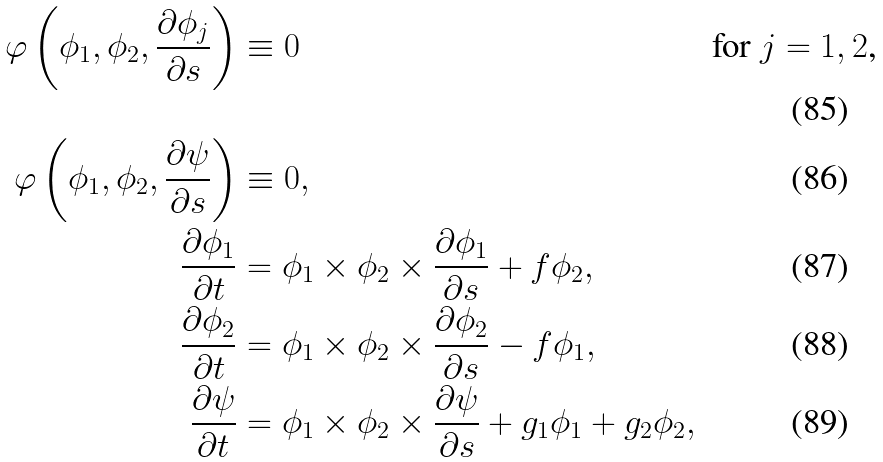Convert formula to latex. <formula><loc_0><loc_0><loc_500><loc_500>\varphi \left ( \phi _ { 1 } , \phi _ { 2 } , \frac { \partial \phi _ { j } } { \partial s } \right ) & \equiv 0 & & \text {for $j=1,2$,} \\ \varphi \left ( \phi _ { 1 } , \phi _ { 2 } , \frac { \partial \psi } { \partial s } \right ) & \equiv 0 , & & \\ \frac { \partial \phi _ { 1 } } { \partial t } & = \phi _ { 1 } \times \phi _ { 2 } \times \frac { \partial \phi _ { 1 } } { \partial s } + f \phi _ { 2 } , & & \\ \frac { \partial \phi _ { 2 } } { \partial t } & = \phi _ { 1 } \times \phi _ { 2 } \times \frac { \partial \phi _ { 2 } } { \partial s } - f \phi _ { 1 } , & & \\ \frac { \partial \psi } { \partial t } & = \phi _ { 1 } \times \phi _ { 2 } \times \frac { \partial \psi } { \partial s } + g _ { 1 } \phi _ { 1 } + g _ { 2 } \phi _ { 2 } , & &</formula> 